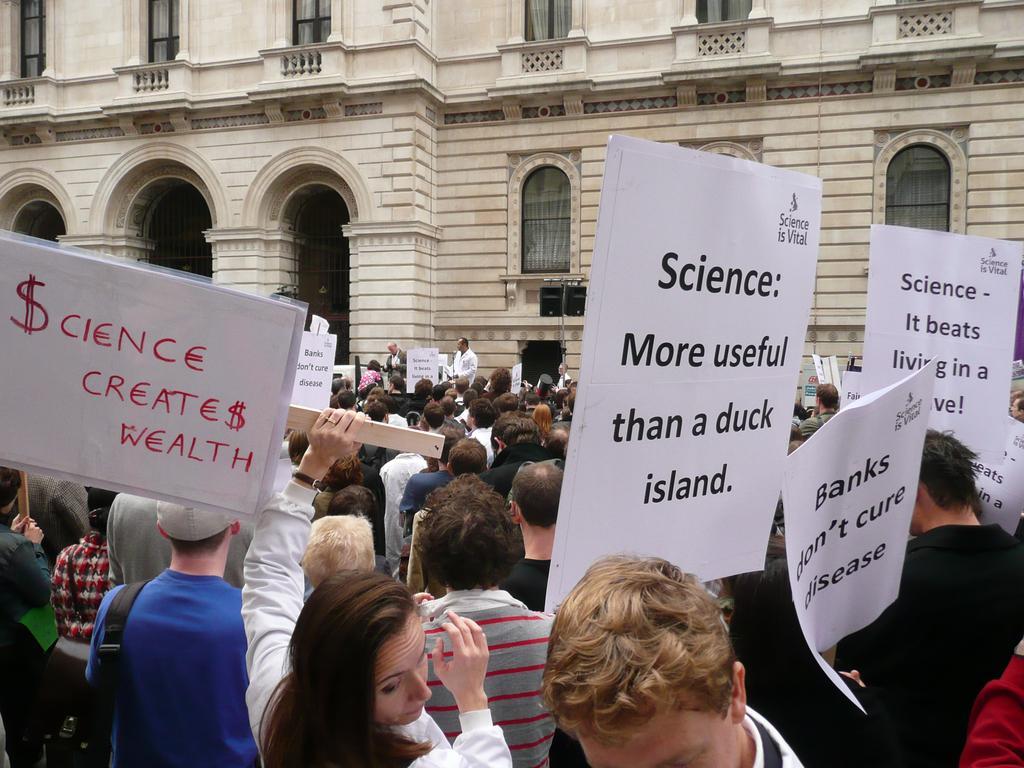Describe this image in one or two sentences. In this image we can see many people. Some are holding placards. In the back there is a building with windows and arches. 